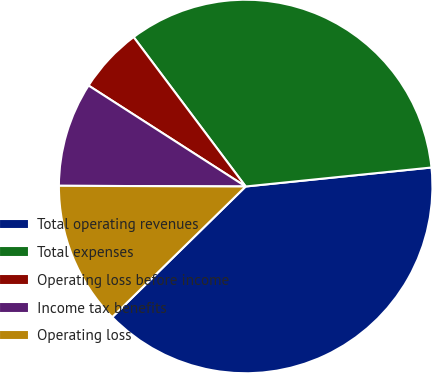Convert chart. <chart><loc_0><loc_0><loc_500><loc_500><pie_chart><fcel>Total operating revenues<fcel>Total expenses<fcel>Operating loss before income<fcel>Income tax benefits<fcel>Operating loss<nl><fcel>39.29%<fcel>33.62%<fcel>5.67%<fcel>9.03%<fcel>12.39%<nl></chart> 